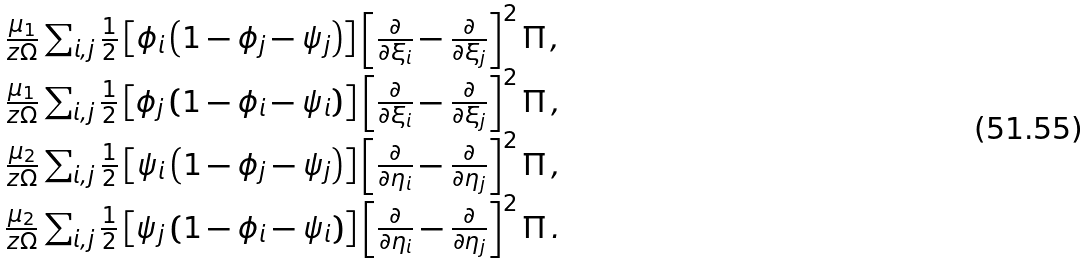Convert formula to latex. <formula><loc_0><loc_0><loc_500><loc_500>\begin{array} { c } \frac { \mu _ { 1 } } { z \Omega } \sum _ { i , j } \frac { 1 } { 2 } \left [ \phi _ { i } \left ( 1 - \phi _ { j } - \psi _ { j } \right ) \right ] \left [ \frac { \partial } { \partial \xi _ { i } } - \frac { \partial } { \partial \xi _ { j } } \right ] ^ { 2 } \Pi \, , \\ \frac { \mu _ { 1 } } { z \Omega } \sum _ { i , j } \frac { 1 } { 2 } \left [ \phi _ { j } \left ( 1 - \phi _ { i } - \psi _ { i } \right ) \right ] \left [ \frac { \partial } { \partial \xi _ { i } } - \frac { \partial } { \partial \xi _ { j } } \right ] ^ { 2 } \Pi \, , \\ \frac { \mu _ { 2 } } { z \Omega } \sum _ { i , j } \frac { 1 } { 2 } \left [ \psi _ { i } \left ( 1 - \phi _ { j } - \psi _ { j } \right ) \right ] \left [ \frac { \partial } { \partial \eta _ { i } } - \frac { \partial } { \partial \eta _ { j } } \right ] ^ { 2 } \Pi \, , \\ \frac { \mu _ { 2 } } { z \Omega } \sum _ { i , j } \frac { 1 } { 2 } \left [ \psi _ { j } \left ( 1 - \phi _ { i } - \psi _ { i } \right ) \right ] \left [ \frac { \partial } { \partial \eta _ { i } } - \frac { \partial } { \partial \eta _ { j } } \right ] ^ { 2 } \Pi \, . \end{array}</formula> 